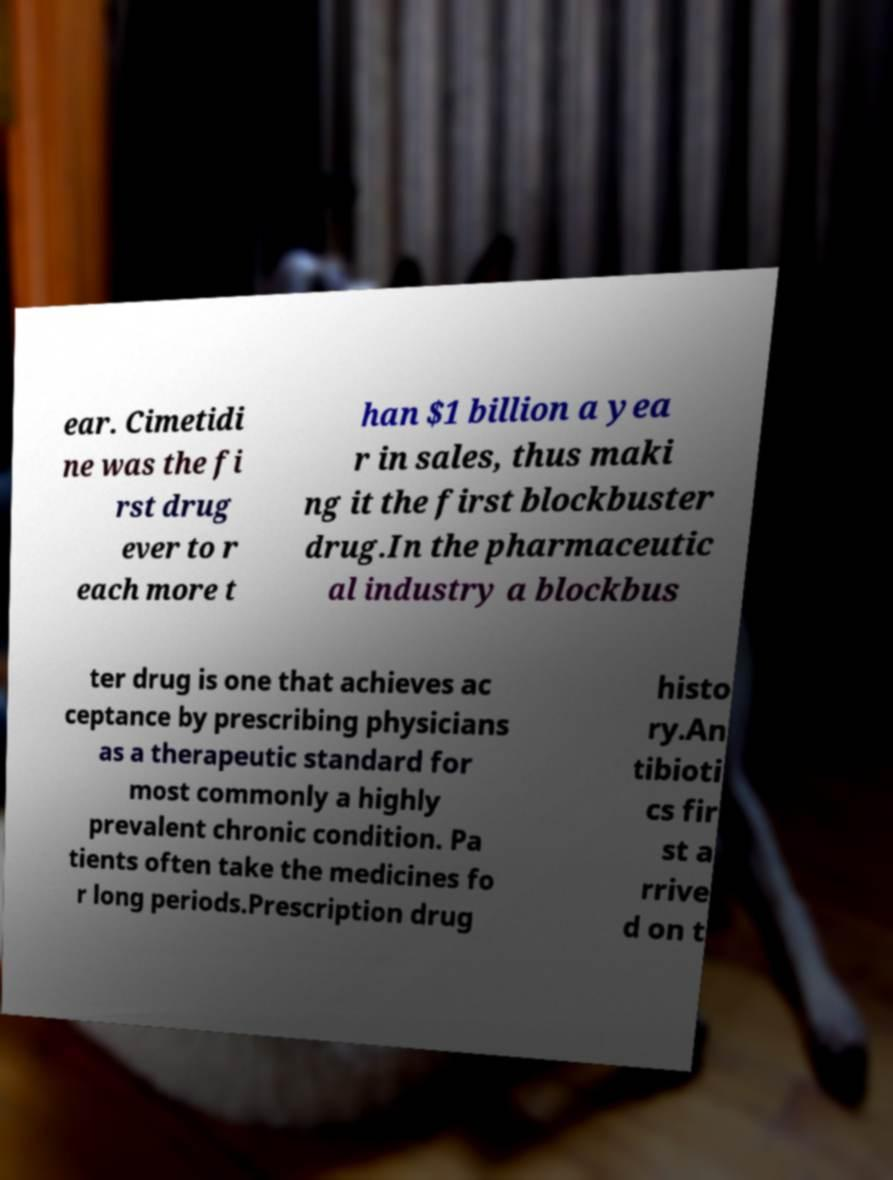Could you extract and type out the text from this image? ear. Cimetidi ne was the fi rst drug ever to r each more t han $1 billion a yea r in sales, thus maki ng it the first blockbuster drug.In the pharmaceutic al industry a blockbus ter drug is one that achieves ac ceptance by prescribing physicians as a therapeutic standard for most commonly a highly prevalent chronic condition. Pa tients often take the medicines fo r long periods.Prescription drug histo ry.An tibioti cs fir st a rrive d on t 